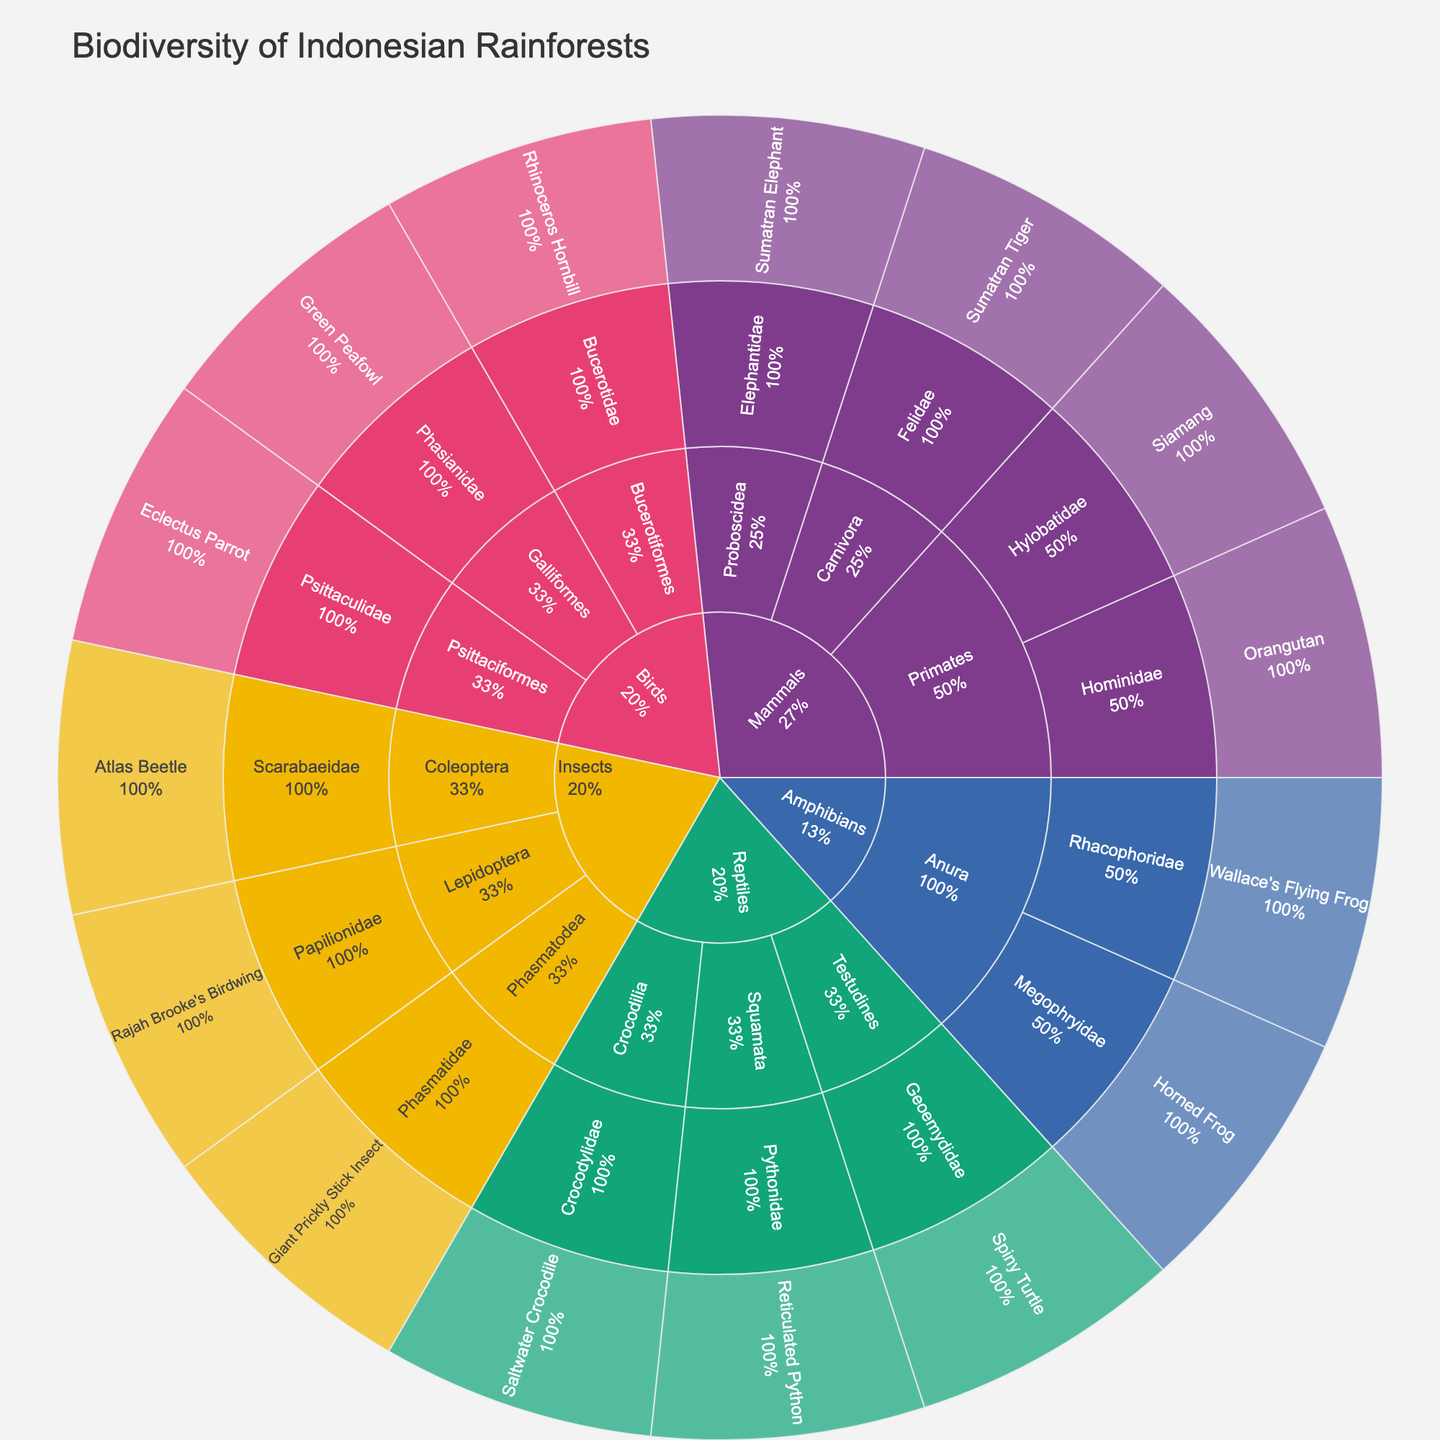What is the title of the sunburst plot? The title of the plot is prominently displayed at the top, indicating the subject or theme of the visualization.
Answer: Biodiversity of Indonesian Rainforests Which class has the most species represented in the sunburst plot? By observing the segments of each class and counting the species, we can determine which class has the most extensive representation. Visually, the largest segment will signify this.
Answer: Insects List two species found under the 'Primates' order in the 'Mammals' class. Navigating through the hierarchy, starting from the 'Mammals' class and going down to the 'Primates' order, the species under this category can be identified.
Answer: Orangutan, Siamang How many orders are there in the 'Birds' class? By examining the subdivisions branching from the 'Birds' class, we can count each distinct order represented in the plot.
Answer: 3 Which species belongs to the ‘Pythonidae’ family in the 'Reptiles' class? Following the hierarchy from 'Reptiles' to 'Pythonidae', the species under this family can be found.
Answer: Reticulated Python Compare the number of families in 'Amphibians' and 'Mammals'. Which class has more families? Identify and count the families under both 'Amphibians' and 'Mammals' classes and compare these counts to determine which class has more families.
Answer: Mammals What proportion of the total species does the 'Psittaciformes' order in 'Birds' represent? Identify the number of species within 'Psittaciformes' and divide it by the total number of species represented in the sunburst plot to find the proportion.
Answer: 1/15 (or approximately 6.67%) Which order in 'Reptiles' has only one family represented? By examining the orders under 'Reptiles' and then counting their respective families, identify any order that has only one family.
Answer: Crocodylia Is Wallace's Flying Frog (from the Amphibians class) in the same order as Horned Frog? By checking the hierarchical path under 'Amphibians', find the orders for both Wallace's Flying Frog and Horned Frog to establish if they are in the same order.
Answer: Yes Describe the color pattern used in the sunburst plot for different classes. The color pattern can be identified by observing the colors assigned to the broadest segments, which represent different classes, distinguished by a discrete color sequence.
Answer: Different bold colors for each class (e.g., one color for Mammals, another for Birds, etc.) 